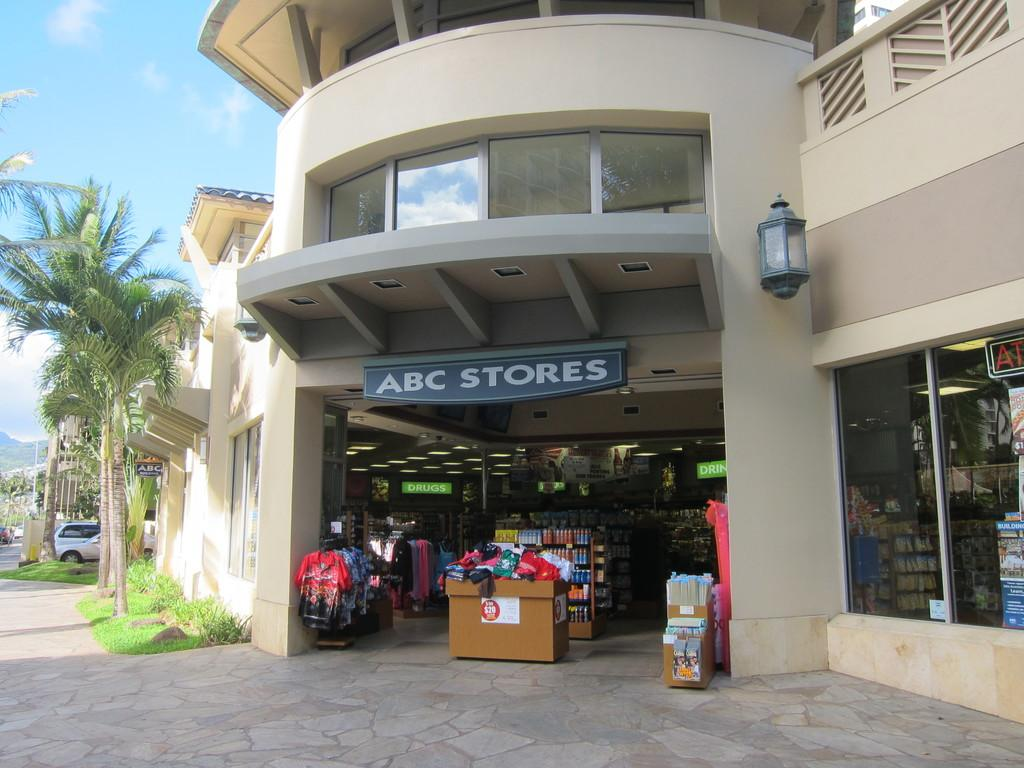What type of establishment is shown in the image? There is a store in the image. What can be found inside the store? There are racks with clothes on them in the image. What other items can be seen in the image? There are boards, grass, plants, glasses, lights, and various objects visible in the image. What is visible in the background of the image? There is a car and sky visible in the background of the image. How many passengers are visible in the image? There are no passengers present in the image. What type of lumber is being used to construct the store in the image? There is no lumber visible in the image, as it focuses on the store's interior and exterior surroundings. 